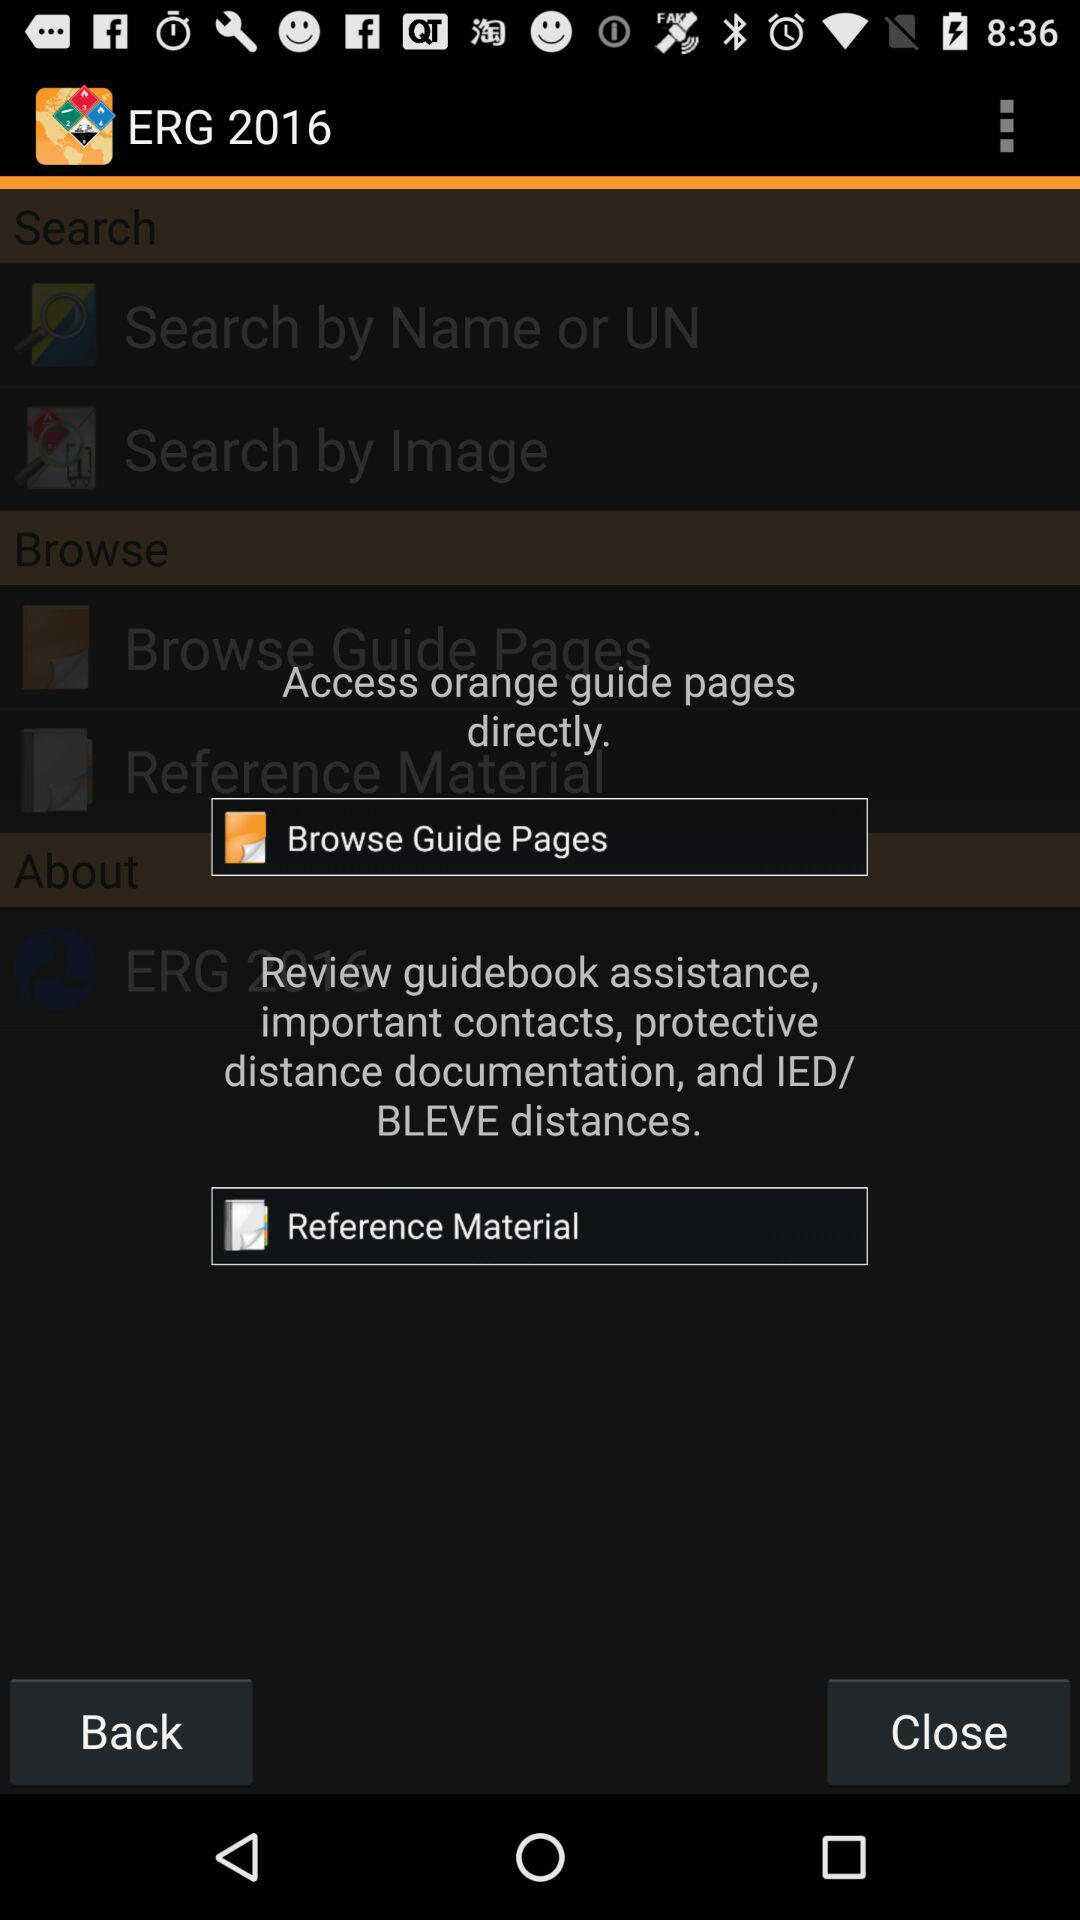What is the app name? The app name is "ERG 2016". 